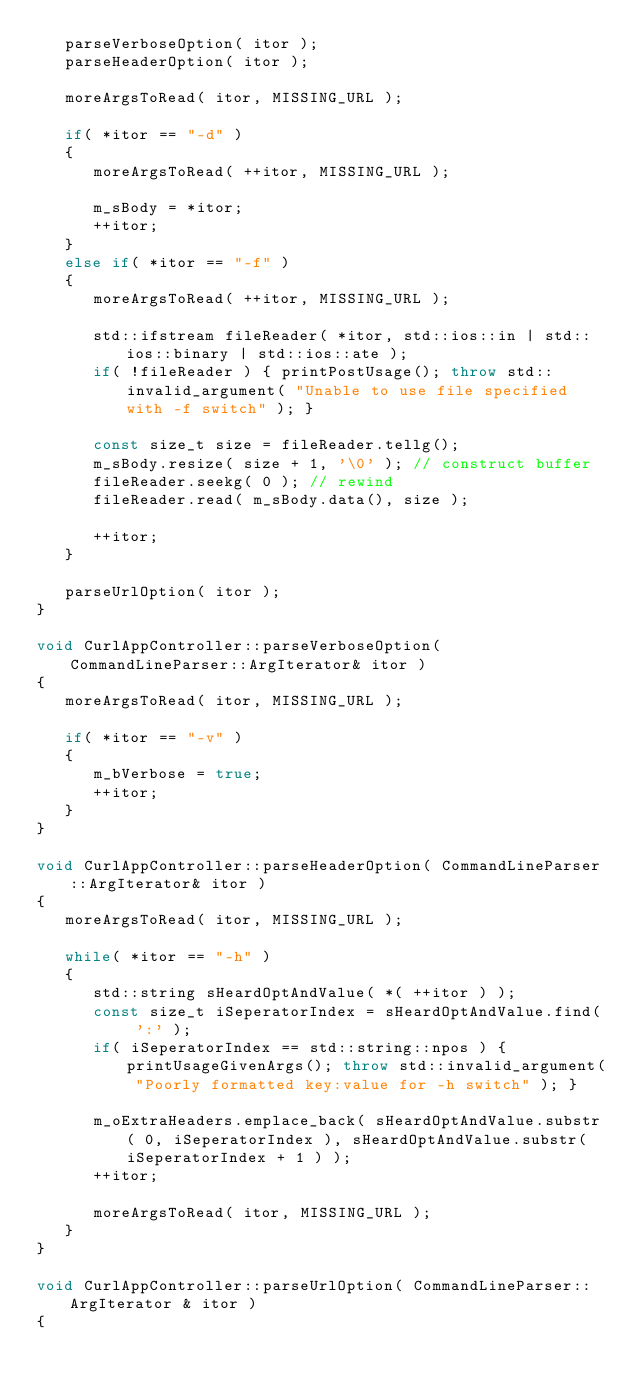<code> <loc_0><loc_0><loc_500><loc_500><_C++_>   parseVerboseOption( itor );
   parseHeaderOption( itor );

   moreArgsToRead( itor, MISSING_URL );

   if( *itor == "-d" )
   {
      moreArgsToRead( ++itor, MISSING_URL );

      m_sBody = *itor;
      ++itor;
   }
   else if( *itor == "-f" )
   {
      moreArgsToRead( ++itor, MISSING_URL );

      std::ifstream fileReader( *itor, std::ios::in | std::ios::binary | std::ios::ate );
      if( !fileReader ) { printPostUsage(); throw std::invalid_argument( "Unable to use file specified with -f switch" ); }

      const size_t size = fileReader.tellg();
      m_sBody.resize( size + 1, '\0' ); // construct buffer
      fileReader.seekg( 0 ); // rewind
      fileReader.read( m_sBody.data(), size );

      ++itor;
   }

   parseUrlOption( itor );
}

void CurlAppController::parseVerboseOption( CommandLineParser::ArgIterator& itor )
{
   moreArgsToRead( itor, MISSING_URL );

   if( *itor == "-v" )
   {
      m_bVerbose = true;
      ++itor;
   }
}

void CurlAppController::parseHeaderOption( CommandLineParser::ArgIterator& itor )
{
   moreArgsToRead( itor, MISSING_URL );

   while( *itor == "-h" )
   {
      std::string sHeardOptAndValue( *( ++itor ) );
      const size_t iSeperatorIndex = sHeardOptAndValue.find( ':' );
      if( iSeperatorIndex == std::string::npos ) { printUsageGivenArgs(); throw std::invalid_argument( "Poorly formatted key:value for -h switch" ); }

      m_oExtraHeaders.emplace_back( sHeardOptAndValue.substr( 0, iSeperatorIndex ), sHeardOptAndValue.substr( iSeperatorIndex + 1 ) );
      ++itor;

      moreArgsToRead( itor, MISSING_URL );
   }
}

void CurlAppController::parseUrlOption( CommandLineParser::ArgIterator & itor )
{</code> 